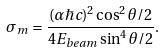<formula> <loc_0><loc_0><loc_500><loc_500>\sigma _ { m } = \frac { ( \alpha \hbar { c } ) ^ { 2 } \cos ^ { 2 } { \theta / 2 } } { 4 E _ { b e a m } \sin ^ { 4 } { \theta / 2 } } .</formula> 